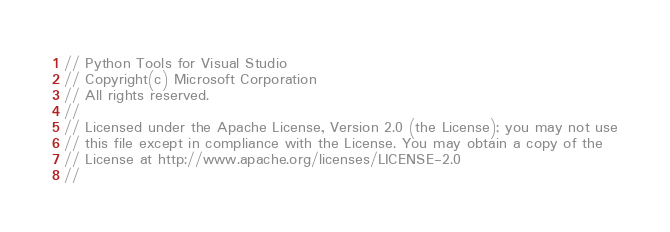Convert code to text. <code><loc_0><loc_0><loc_500><loc_500><_C#_>// Python Tools for Visual Studio
// Copyright(c) Microsoft Corporation
// All rights reserved.
//
// Licensed under the Apache License, Version 2.0 (the License); you may not use
// this file except in compliance with the License. You may obtain a copy of the
// License at http://www.apache.org/licenses/LICENSE-2.0
//</code> 